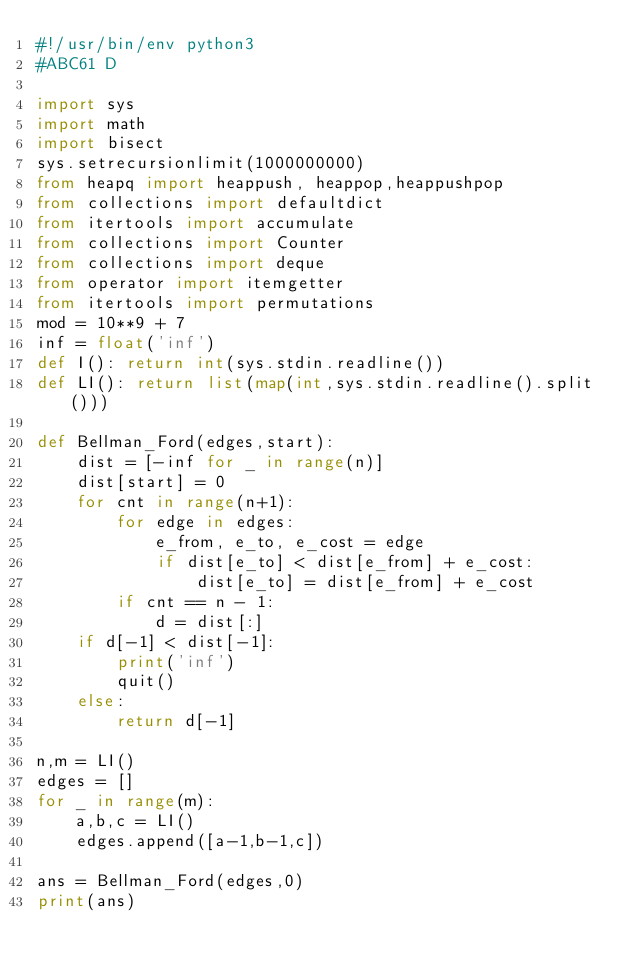<code> <loc_0><loc_0><loc_500><loc_500><_Python_>#!/usr/bin/env python3
#ABC61 D

import sys
import math
import bisect
sys.setrecursionlimit(1000000000)
from heapq import heappush, heappop,heappushpop
from collections import defaultdict
from itertools import accumulate
from collections import Counter
from collections import deque
from operator import itemgetter
from itertools import permutations
mod = 10**9 + 7
inf = float('inf')
def I(): return int(sys.stdin.readline())
def LI(): return list(map(int,sys.stdin.readline().split()))

def Bellman_Ford(edges,start):
    dist = [-inf for _ in range(n)]
    dist[start] = 0
    for cnt in range(n+1):
        for edge in edges:
            e_from, e_to, e_cost = edge
            if dist[e_to] < dist[e_from] + e_cost:
                dist[e_to] = dist[e_from] + e_cost
        if cnt == n - 1:
            d = dist[:]
    if d[-1] < dist[-1]:
        print('inf')
        quit()
    else:
        return d[-1]

n,m = LI()
edges = []
for _ in range(m):
    a,b,c = LI()
    edges.append([a-1,b-1,c])

ans = Bellman_Ford(edges,0)
print(ans)
</code> 